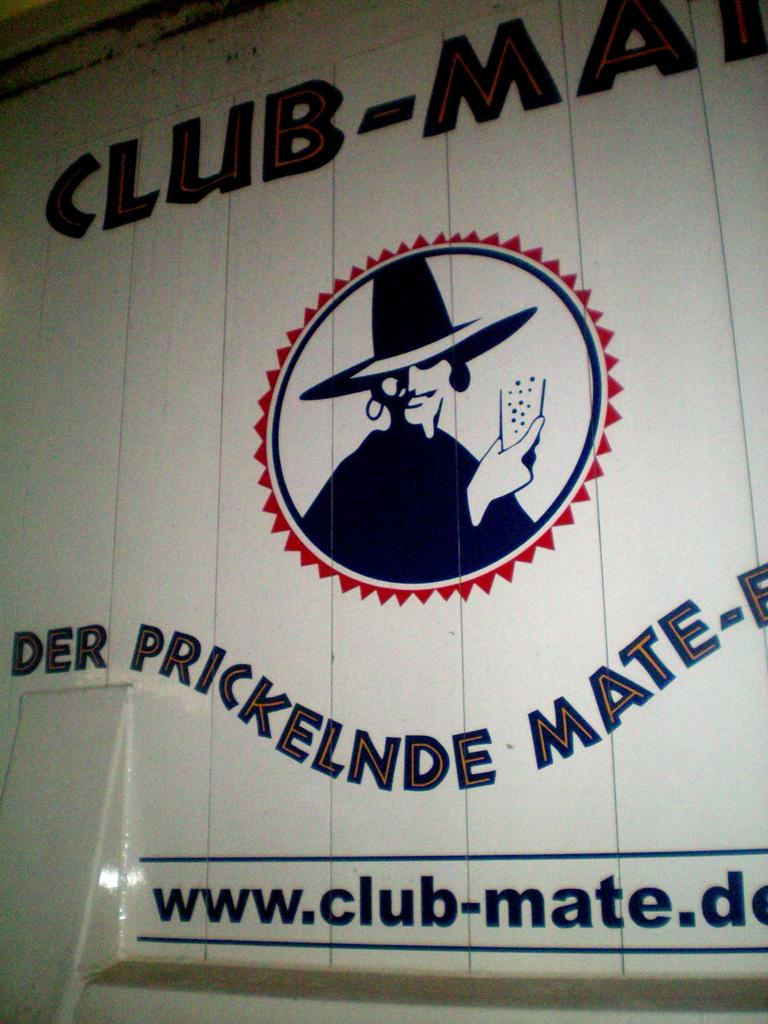What color is the wall in the image? The wall in the image is white. What text can be seen on the wall? The text "CLUB-MAIN" and "DERPRICKELENDE MATE" are written on the wall. What type of flooring is visible in the image? There is no information about the flooring in the image, as the focus is on the wall. 